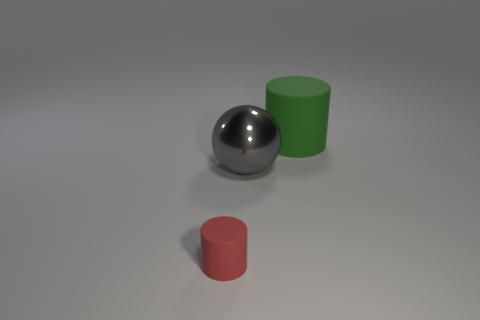Subtract all balls. How many objects are left? 2 Add 1 big spheres. How many objects exist? 4 Subtract all red cylinders. How many cylinders are left? 1 Subtract 1 cylinders. How many cylinders are left? 1 Subtract all cyan cylinders. Subtract all brown spheres. How many cylinders are left? 2 Subtract all tiny cyan shiny cubes. Subtract all big balls. How many objects are left? 2 Add 2 big metallic balls. How many big metallic balls are left? 3 Add 2 tiny red rubber cylinders. How many tiny red rubber cylinders exist? 3 Subtract 0 cyan cubes. How many objects are left? 3 